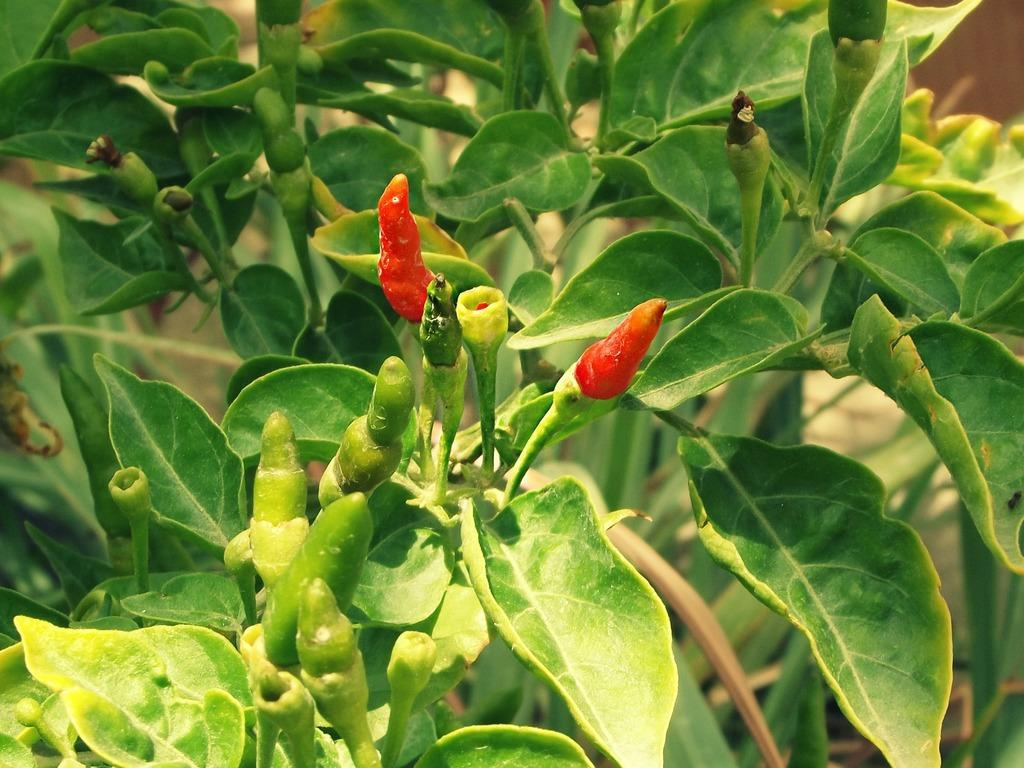What type of plant is depicted in the image? The image features chilies and leaves on the branches of a tree. What are the main components of the plant in the image? The main components of the plant in the image are chilies and leaves. Where are the chilies and leaves located on the plant? The chilies and leaves are on the branches of the tree. What type of crown is visible on the jar in the image? There is no crown or jar present in the image; it features chilies and leaves on the branches of a tree. How many coils can be seen on the plant in the image? The image does not show any coils on the plant; it only features chilies and leaves on the branches of the tree. 